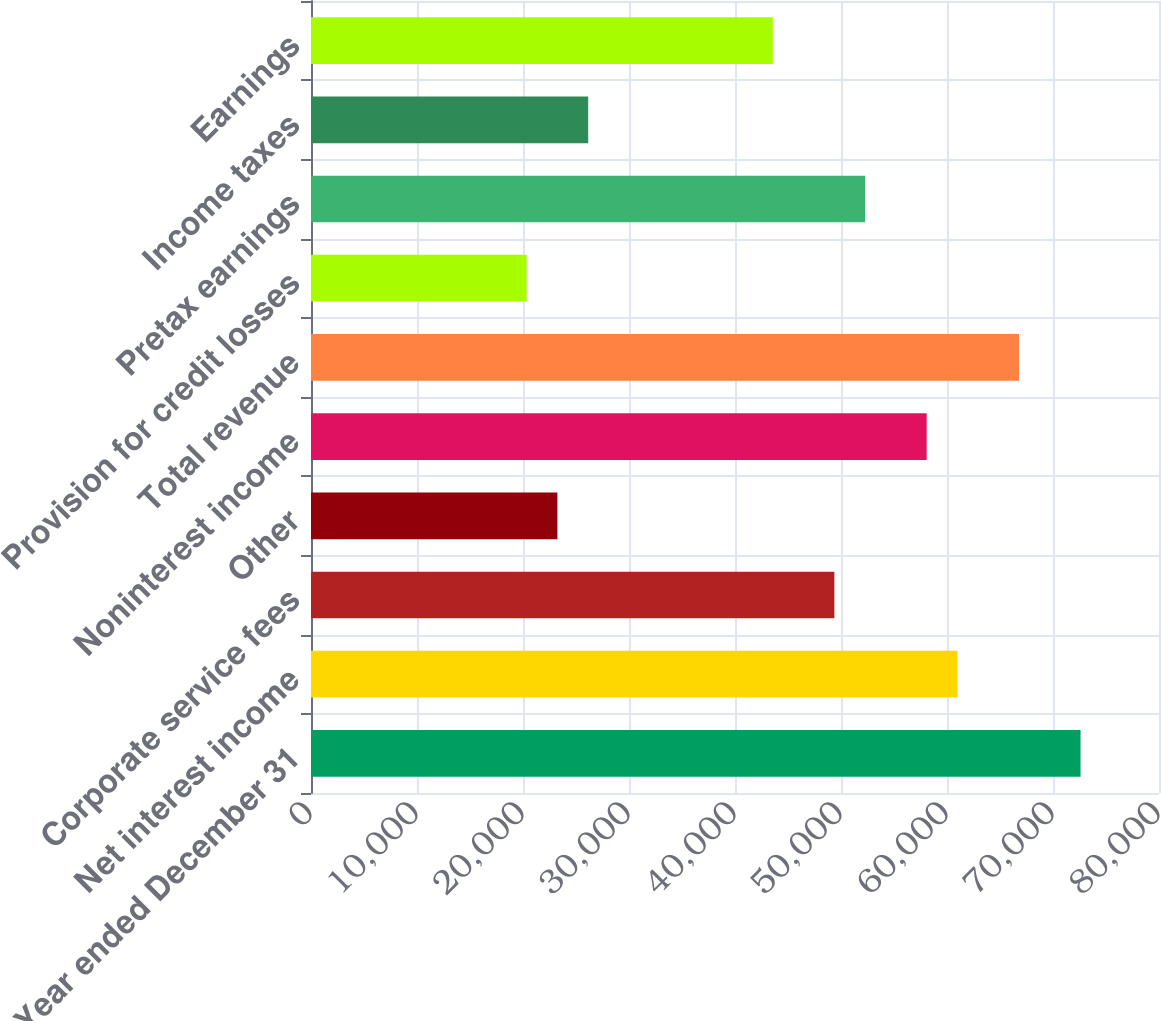Convert chart to OTSL. <chart><loc_0><loc_0><loc_500><loc_500><bar_chart><fcel>Year ended December 31<fcel>Net interest income<fcel>Corporate service fees<fcel>Other<fcel>Noninterest income<fcel>Total revenue<fcel>Provision for credit losses<fcel>Pretax earnings<fcel>Income taxes<fcel>Earnings<nl><fcel>72600<fcel>60987.2<fcel>49374.4<fcel>23245.6<fcel>58084<fcel>66793.6<fcel>20342.4<fcel>52277.6<fcel>26148.8<fcel>43568<nl></chart> 